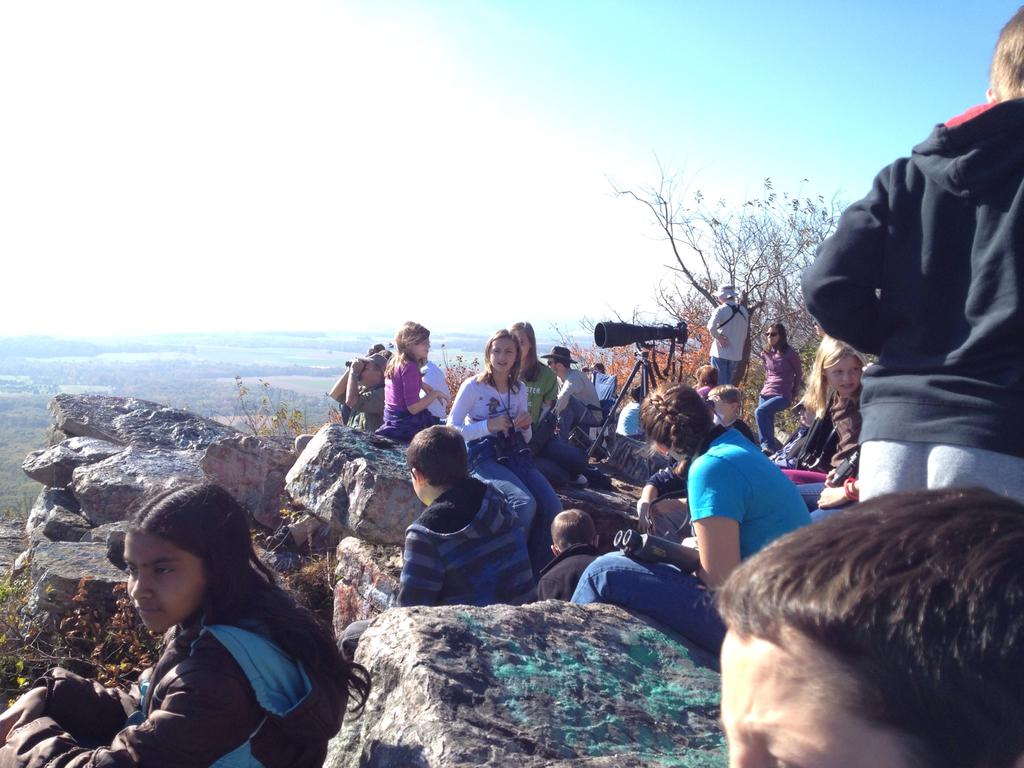What are the persons in the image doing? Some persons are sitting on the rocks, while others are standing on the ground. What objects are present that might be related to photography? Cameras and tripods are visible in the image. What type of natural environment is present in the image? Trees are present in the image, and the sky is visible with clouds. What is the rate of the basketball game in the image? There is no basketball game present in the image, so it is not possible to determine the rate. 